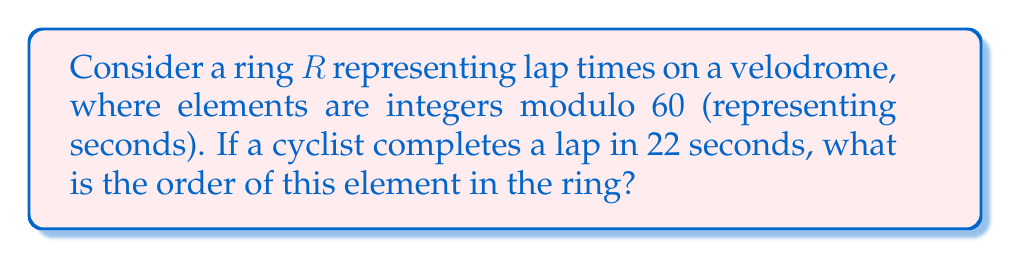Could you help me with this problem? To solve this problem, we need to understand the concept of order in a ring and how it applies to modular arithmetic:

1) In a ring $R$, the order of an element $a$ is the smallest positive integer $n$ such that $na = 0$ (where $0$ is the additive identity of the ring).

2) In this case, our ring $R$ is $\mathbb{Z}_{60}$ (integers modulo 60), and we're looking at the element $22$.

3) We need to find the smallest positive integer $n$ such that $22n \equiv 0 \pmod{60}$.

4) This is equivalent to finding the smallest $n$ where 60 divides $22n$.

5) We can express this mathematically as:
   $$ 22n = 60k \text{ for some integer } k $$

6) Simplifying:
   $$ 11n = 30k $$

7) The smallest $n$ that satisfies this is when $n = 30$ and $k = 11$.

8) We can verify:
   $$ 22 \cdot 30 = 660 \equiv 0 \pmod{60} $$

9) Therefore, the order of 22 in $\mathbb{Z}_{60}$ is 30.

This means that after 30 laps, the cyclist will cross the finish line at exactly 0 seconds on the clock (modulo 60).
Answer: The order of the element 22 in the ring $\mathbb{Z}_{60}$ is 30. 